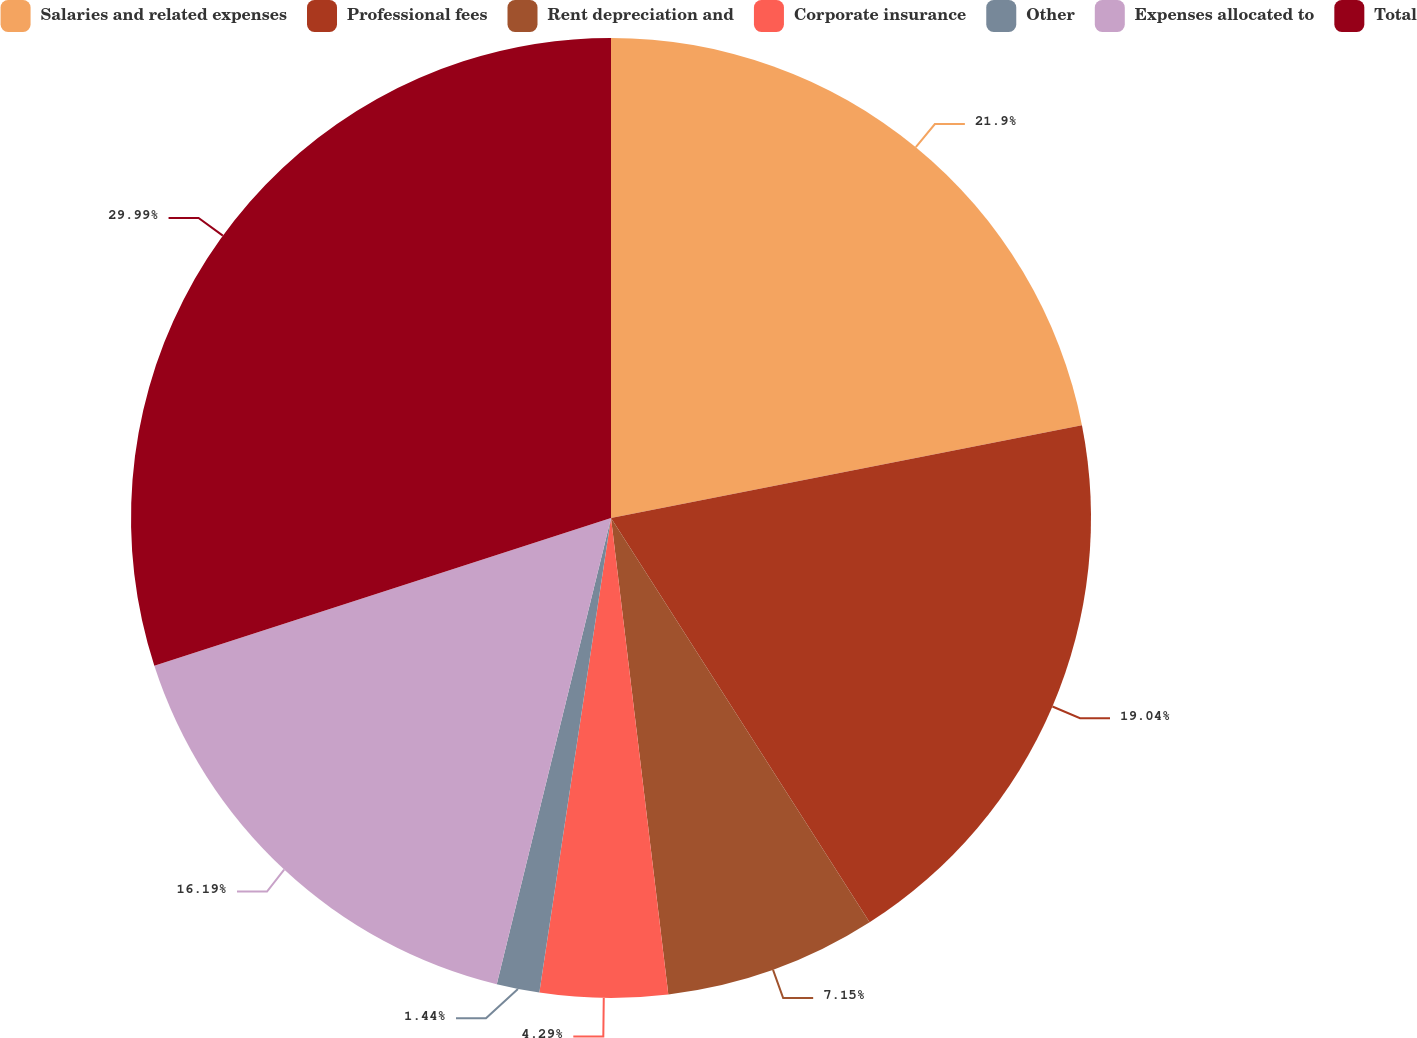Convert chart to OTSL. <chart><loc_0><loc_0><loc_500><loc_500><pie_chart><fcel>Salaries and related expenses<fcel>Professional fees<fcel>Rent depreciation and<fcel>Corporate insurance<fcel>Other<fcel>Expenses allocated to<fcel>Total<nl><fcel>21.9%<fcel>19.04%<fcel>7.15%<fcel>4.29%<fcel>1.44%<fcel>16.19%<fcel>29.98%<nl></chart> 